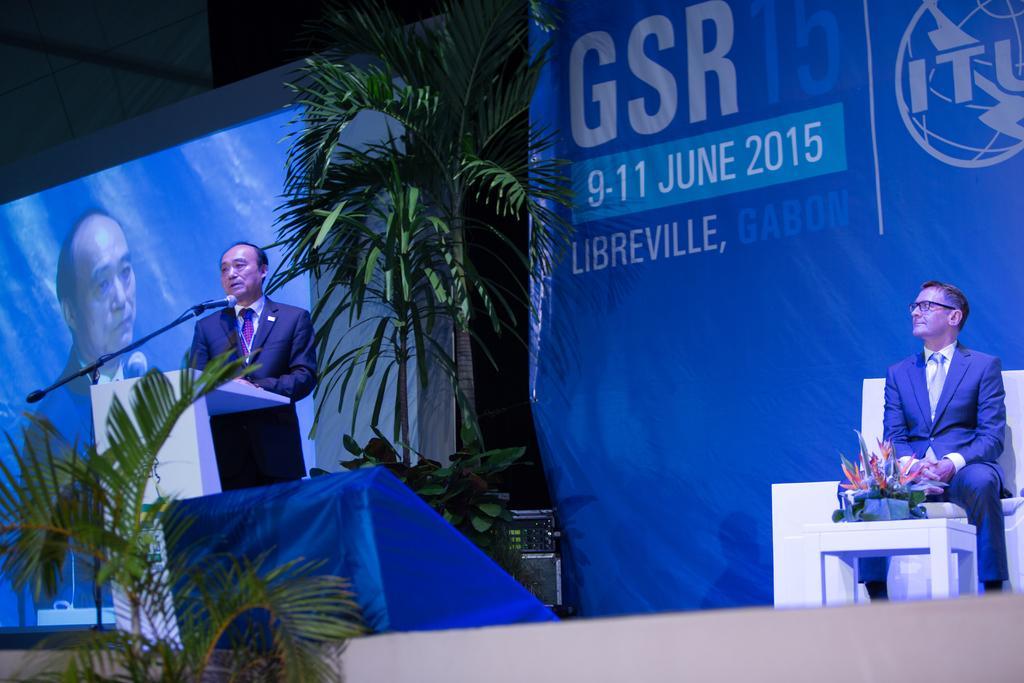Can you describe this image briefly? In this picture we can see two men, one is seated on the chair and another man is standing, in front of him we can see a microphone, and we can find few plants, hoarding, on the left side of the image we can see a screen. 